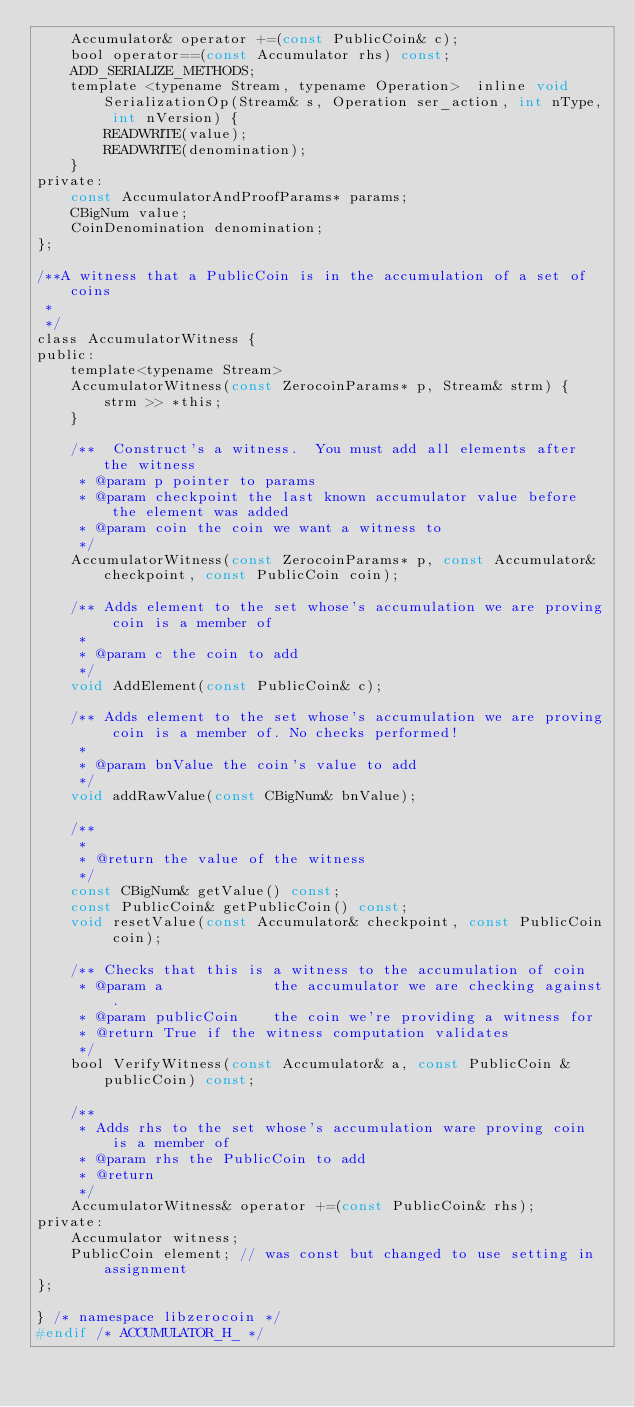Convert code to text. <code><loc_0><loc_0><loc_500><loc_500><_C_>    Accumulator& operator +=(const PublicCoin& c);
    bool operator==(const Accumulator rhs) const;
    ADD_SERIALIZE_METHODS;
    template <typename Stream, typename Operation>  inline void SerializationOp(Stream& s, Operation ser_action, int nType, int nVersion) {
        READWRITE(value);
        READWRITE(denomination);
    }
private:
    const AccumulatorAndProofParams* params;
    CBigNum value;
    CoinDenomination denomination;
};

/**A witness that a PublicCoin is in the accumulation of a set of coins
 *
 */
class AccumulatorWitness {
public:
    template<typename Stream>
    AccumulatorWitness(const ZerocoinParams* p, Stream& strm) {
        strm >> *this;
    }

    /**  Construct's a witness.  You must add all elements after the witness
     * @param p pointer to params
     * @param checkpoint the last known accumulator value before the element was added
     * @param coin the coin we want a witness to
     */
    AccumulatorWitness(const ZerocoinParams* p, const Accumulator& checkpoint, const PublicCoin coin);

    /** Adds element to the set whose's accumulation we are proving coin is a member of
     *
     * @param c the coin to add
     */
    void AddElement(const PublicCoin& c);

    /** Adds element to the set whose's accumulation we are proving coin is a member of. No checks performed!
     *
     * @param bnValue the coin's value to add
     */
    void addRawValue(const CBigNum& bnValue);

    /**
     *
     * @return the value of the witness
     */
    const CBigNum& getValue() const;
    const PublicCoin& getPublicCoin() const;
    void resetValue(const Accumulator& checkpoint, const PublicCoin coin);

    /** Checks that this is a witness to the accumulation of coin
     * @param a             the accumulator we are checking against.
     * @param publicCoin    the coin we're providing a witness for
     * @return True if the witness computation validates
     */
    bool VerifyWitness(const Accumulator& a, const PublicCoin &publicCoin) const;

    /**
     * Adds rhs to the set whose's accumulation ware proving coin is a member of
     * @param rhs the PublicCoin to add
     * @return
     */
    AccumulatorWitness& operator +=(const PublicCoin& rhs);
private:
    Accumulator witness;
    PublicCoin element; // was const but changed to use setting in assignment
};

} /* namespace libzerocoin */
#endif /* ACCUMULATOR_H_ */
</code> 